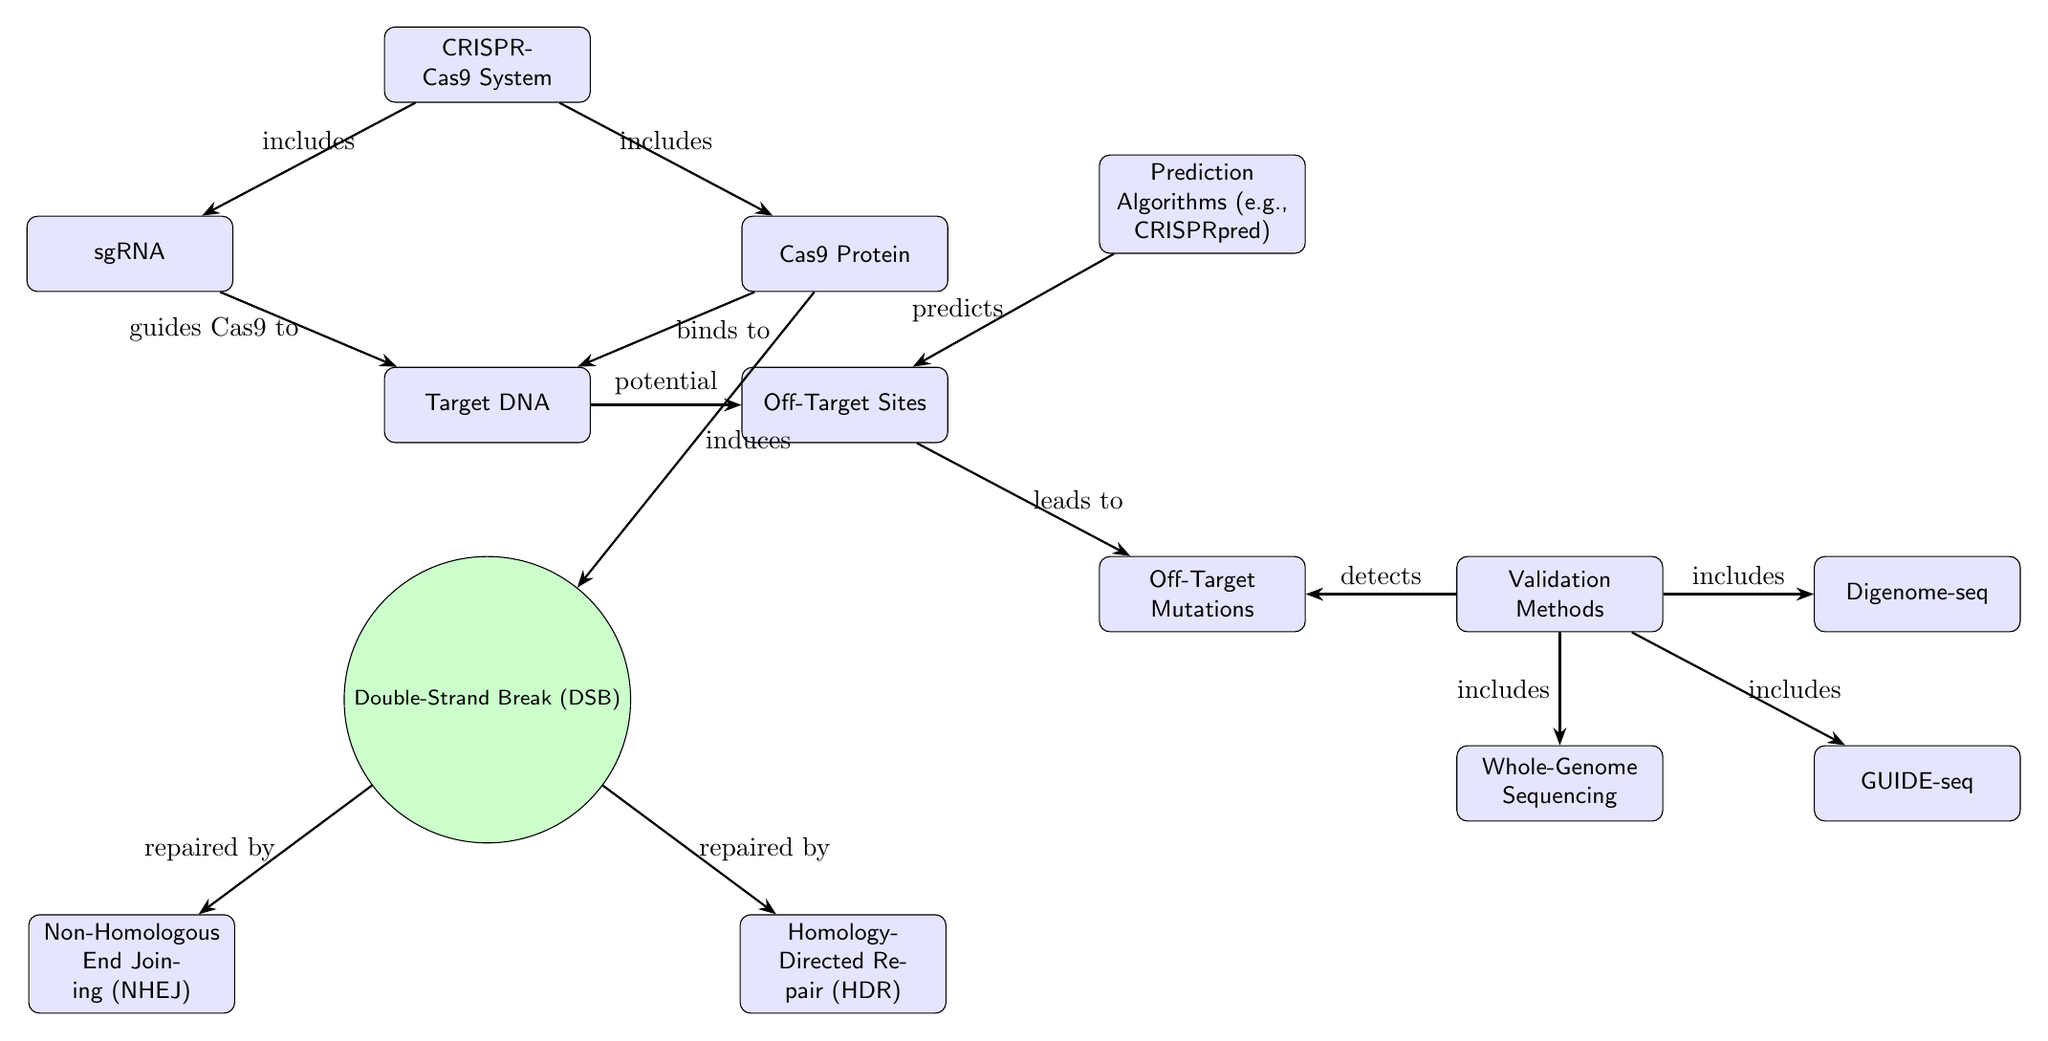What does sgRNA guide in the CRISPR-Cas9 system? In the diagram, sgRNA points to the 'Target DNA' node, indicating that it provides guidance to the Cas9 protein for the specific DNA sequence it is intended to modify.
Answer: Target DNA What does Cas9 do after binding to the target DNA? The diagram shows an arrow from the 'Cas9 Protein' to the 'Double-Strand Break (DSB)' node, indicating that upon binding to the target DNA, the Cas9 protein induces a double-strand break in the DNA.
Answer: Induces How many methods are listed for validating off-target mutations? The diagram lists three methods that flow out from the 'Validation Methods' node: 'Whole-Genome Sequencing', 'GUIDE-seq', and 'Digenome-seq'. Therefore, there are three methods depicted.
Answer: 3 What is predicted by the prediction algorithms shown in the diagram? The 'Prediction Algorithms' node points to the 'Off-Target Sites' node, indicating that these algorithms are used to predict possible off-target sites where unintended modifications may occur.
Answer: Off-Target Sites Which two processes are responsible for repairing the double-strand break? The 'Double-Strand Break (DSB)' node connects to two entities: 'Non-Homologous End Joining (NHEJ)' and 'Homology-Directed Repair (HDR)', indicating that both processes are involved in repairing the double-strand break.
Answer: NHEJ and HDR What leads to off-target mutations according to the diagram? The diagram shows that 'Off-Target Sites' leads to 'Off-Target Mutations'. This suggests that the presence of off-target sites results in the occurrence of mutations in those regions.
Answer: Leads to What is included in the CRISPR-Cas9 system? The diagram indicates that both 'sgRNA' and 'Cas9 Protein' are included within the 'CRISPR-Cas9 System' node, as there are arrows pointing from the system to these two components.
Answer: sgRNA and Cas9 Protein Which component detects off-target mutations? The arrow from 'Validation Methods' to 'Off-Target Mutations' indicates that validation methods are used to detect off-target mutations.
Answer: Validation Methods 